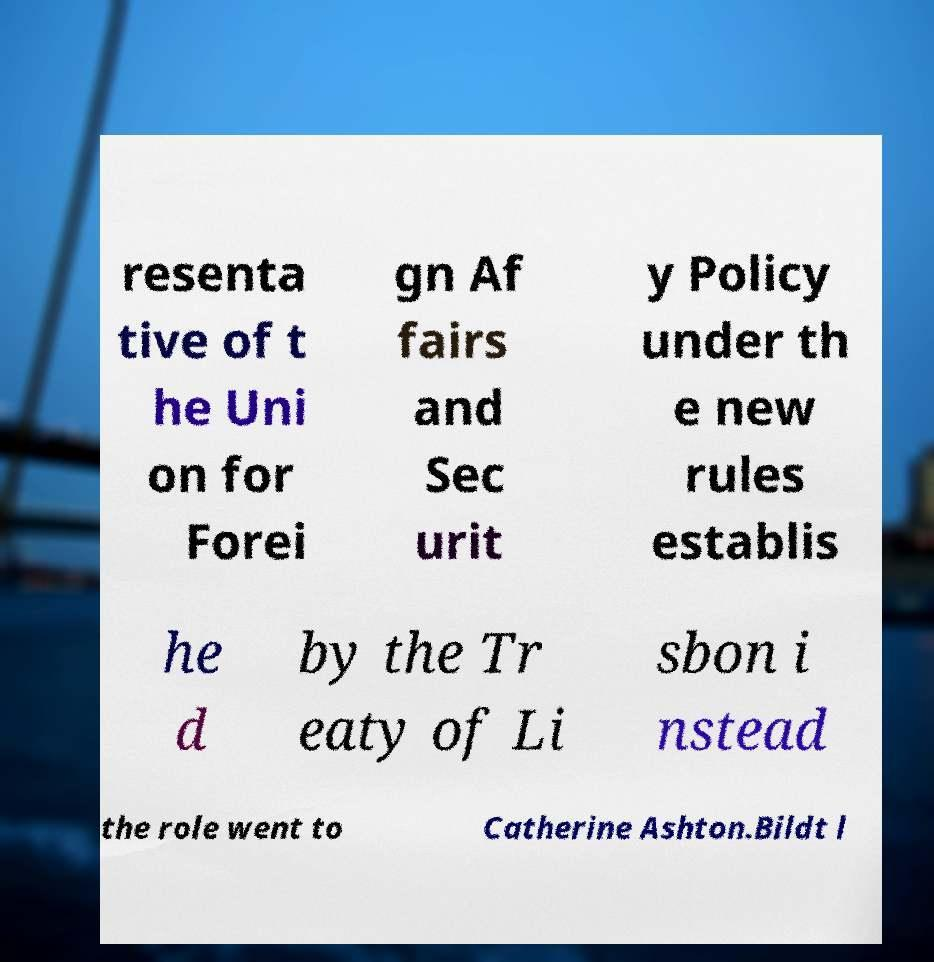For documentation purposes, I need the text within this image transcribed. Could you provide that? resenta tive of t he Uni on for Forei gn Af fairs and Sec urit y Policy under th e new rules establis he d by the Tr eaty of Li sbon i nstead the role went to Catherine Ashton.Bildt l 